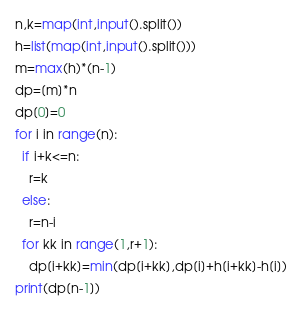Convert code to text. <code><loc_0><loc_0><loc_500><loc_500><_Python_>n,k=map(int,input().split())
h=list(map(int,input().split()))
m=max(h)*(n-1)
dp=[m]*n
dp[0]=0
for i in range(n):
  if i+k<=n:
    r=k
  else:
    r=n-i
  for kk in range(1,r+1):
    dp[i+kk]=min(dp[i+kk],dp[i]+h[i+kk]-h[i])
print(dp[n-1])</code> 